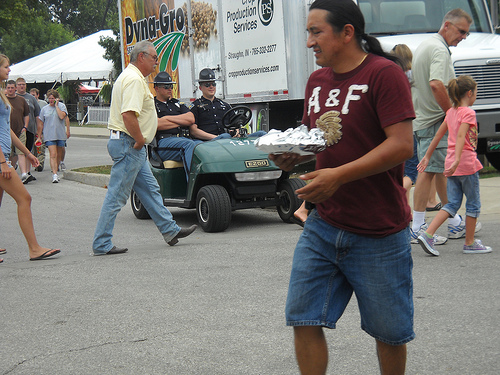<image>
Can you confirm if the man is to the left of the man? Yes. From this viewpoint, the man is positioned to the left side relative to the man. 